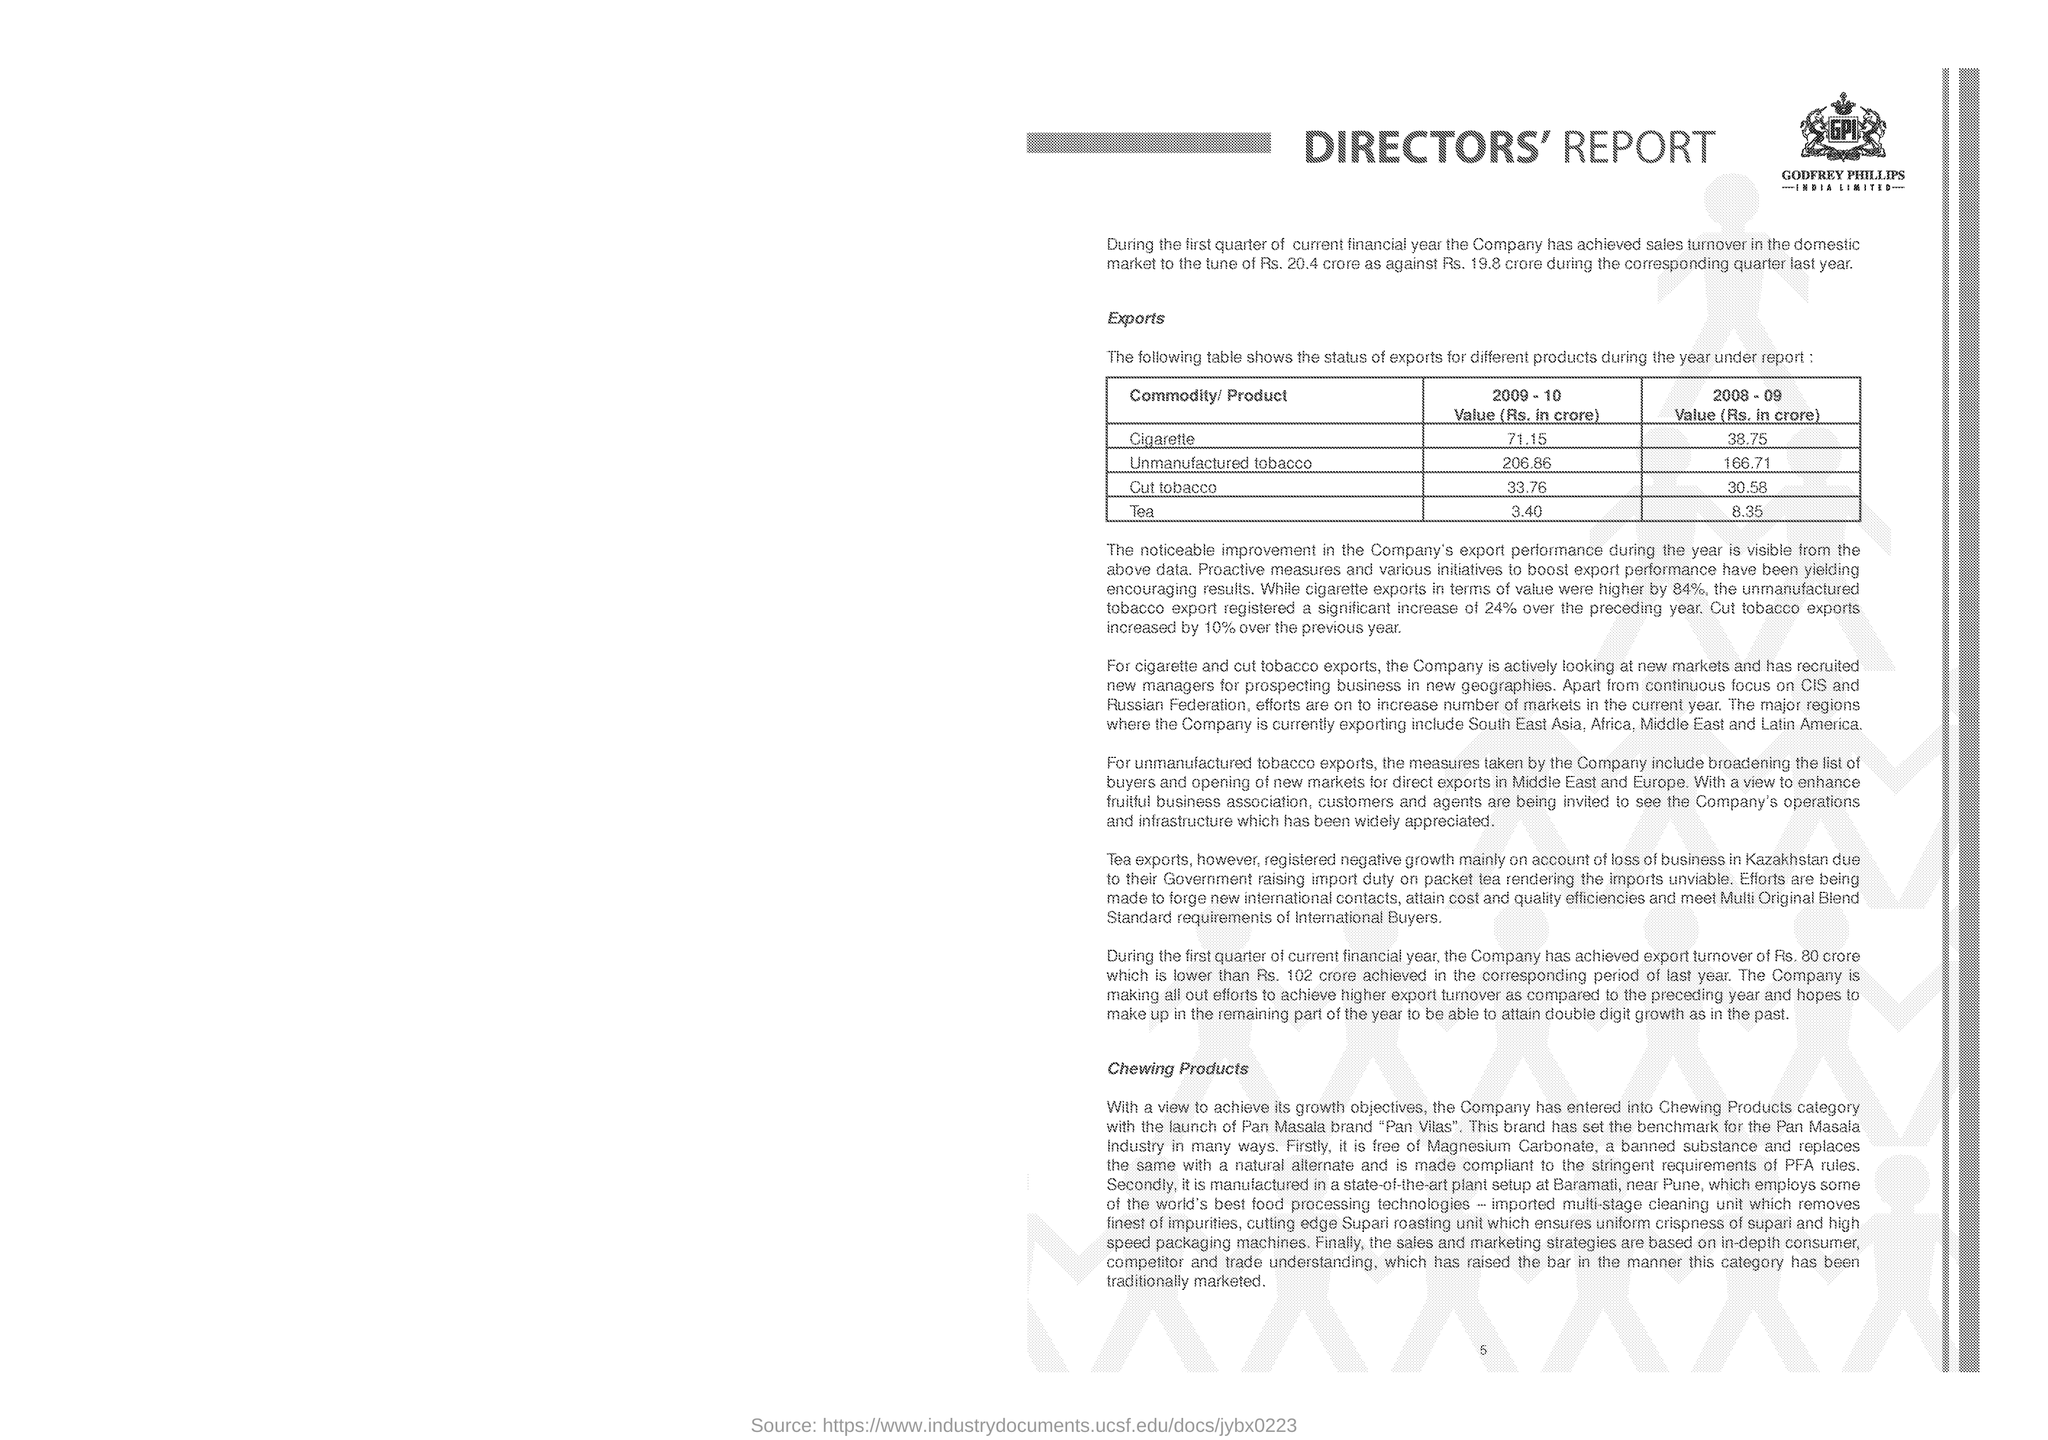Mention a couple of crucial points in this snapshot. In the year 2009-10, the export value of unmanufactured tobacco was Rs. 206.86 crores. The export value of tea in the year 2008-09 was 8.35 crore rupees. The export value for cigarettes in the year 2009-2010 was 71.15 crore rupees. In the year 2008-09, the export value of cut tobacco was 30.58 crore Indian Rupees. 